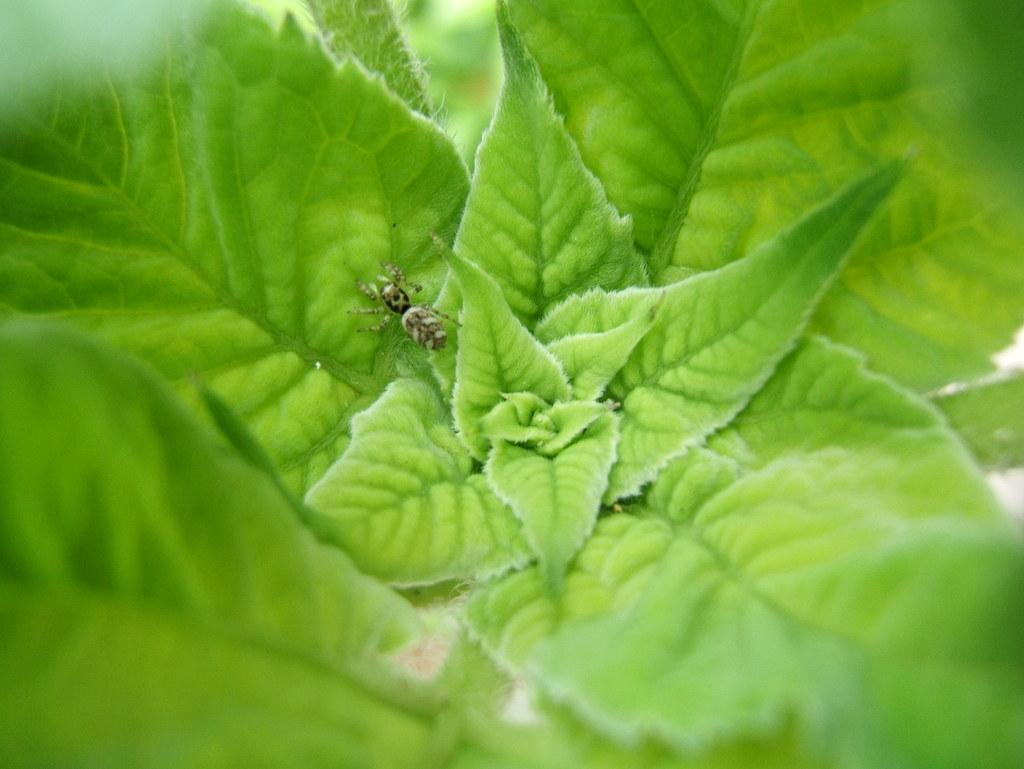What type of vegetation can be seen in the image? There are green leaves in the image. Can you describe any living organisms present on the leaves? Yes, there is an insect on a leaf in the image. What type of apparel is the insect wearing in the image? Insects do not wear apparel, so this question cannot be answered. 